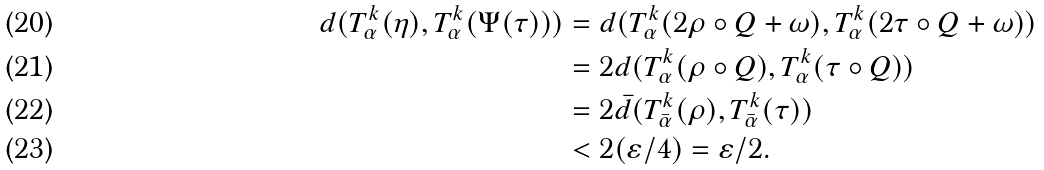<formula> <loc_0><loc_0><loc_500><loc_500>d ( T ^ { k } _ { \alpha } ( \eta ) , T ^ { k } _ { \alpha } ( \Psi ( \tau ) ) ) & = d ( T ^ { k } _ { \alpha } ( 2 \rho \circ Q + \omega ) , T ^ { k } _ { \alpha } ( 2 \tau \circ Q + \omega ) ) \\ & = 2 d ( T ^ { k } _ { \alpha } ( \rho \circ Q ) , T ^ { k } _ { \alpha } ( \tau \circ Q ) ) \\ & = 2 \bar { d } ( T ^ { k } _ { \bar { \alpha } } ( \rho ) , T ^ { k } _ { \bar { \alpha } } ( \tau ) ) \\ & < 2 ( \varepsilon / 4 ) = \varepsilon / 2 .</formula> 